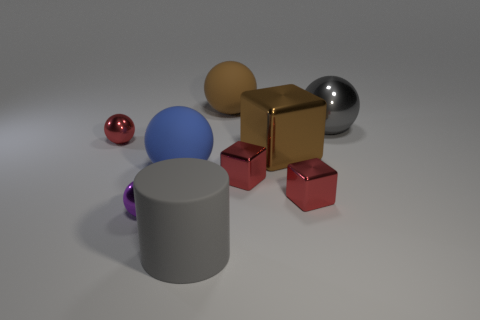Is the color of the large matte cylinder the same as the large metal ball? No, the colors are different. The large matte cylinder has a neutral grey color, while the large metal ball appears to have a reflective silver surface, which shows some level of glossiness and reflects the environment differently than the matte surface. 